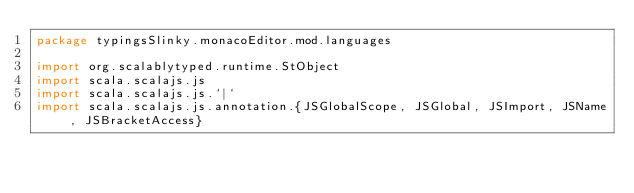Convert code to text. <code><loc_0><loc_0><loc_500><loc_500><_Scala_>package typingsSlinky.monacoEditor.mod.languages

import org.scalablytyped.runtime.StObject
import scala.scalajs.js
import scala.scalajs.js.`|`
import scala.scalajs.js.annotation.{JSGlobalScope, JSGlobal, JSImport, JSName, JSBracketAccess}
</code> 